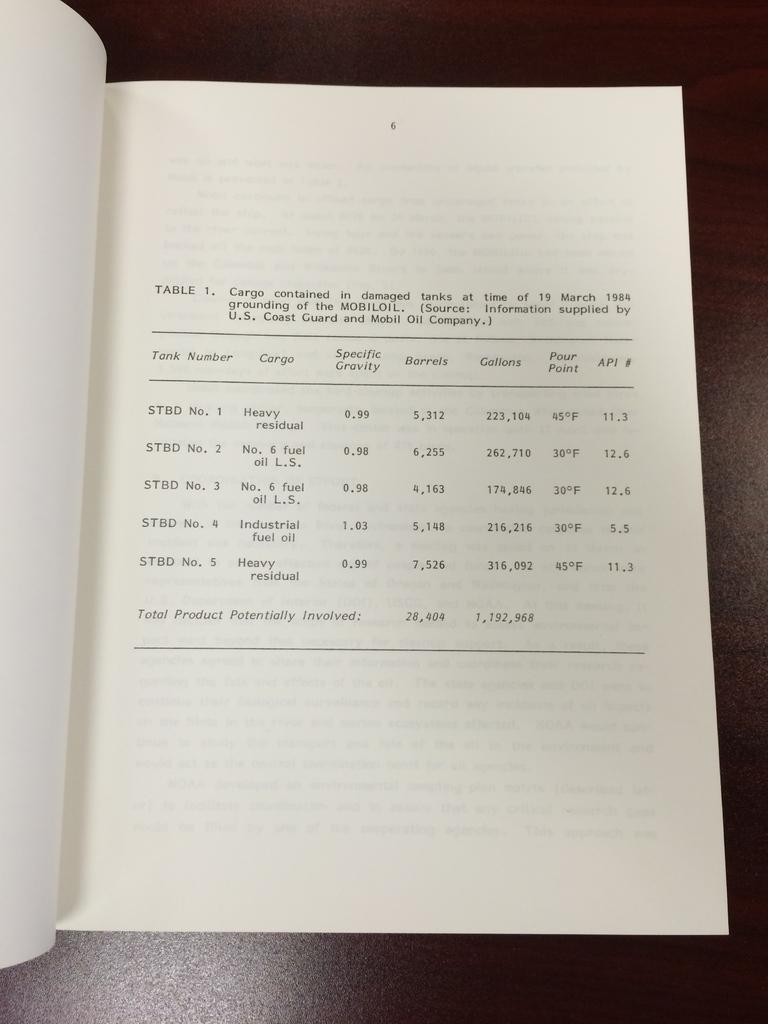<image>
Create a compact narrative representing the image presented. A book opened to page 1 shows a table about cargo contained in damaged tanks 